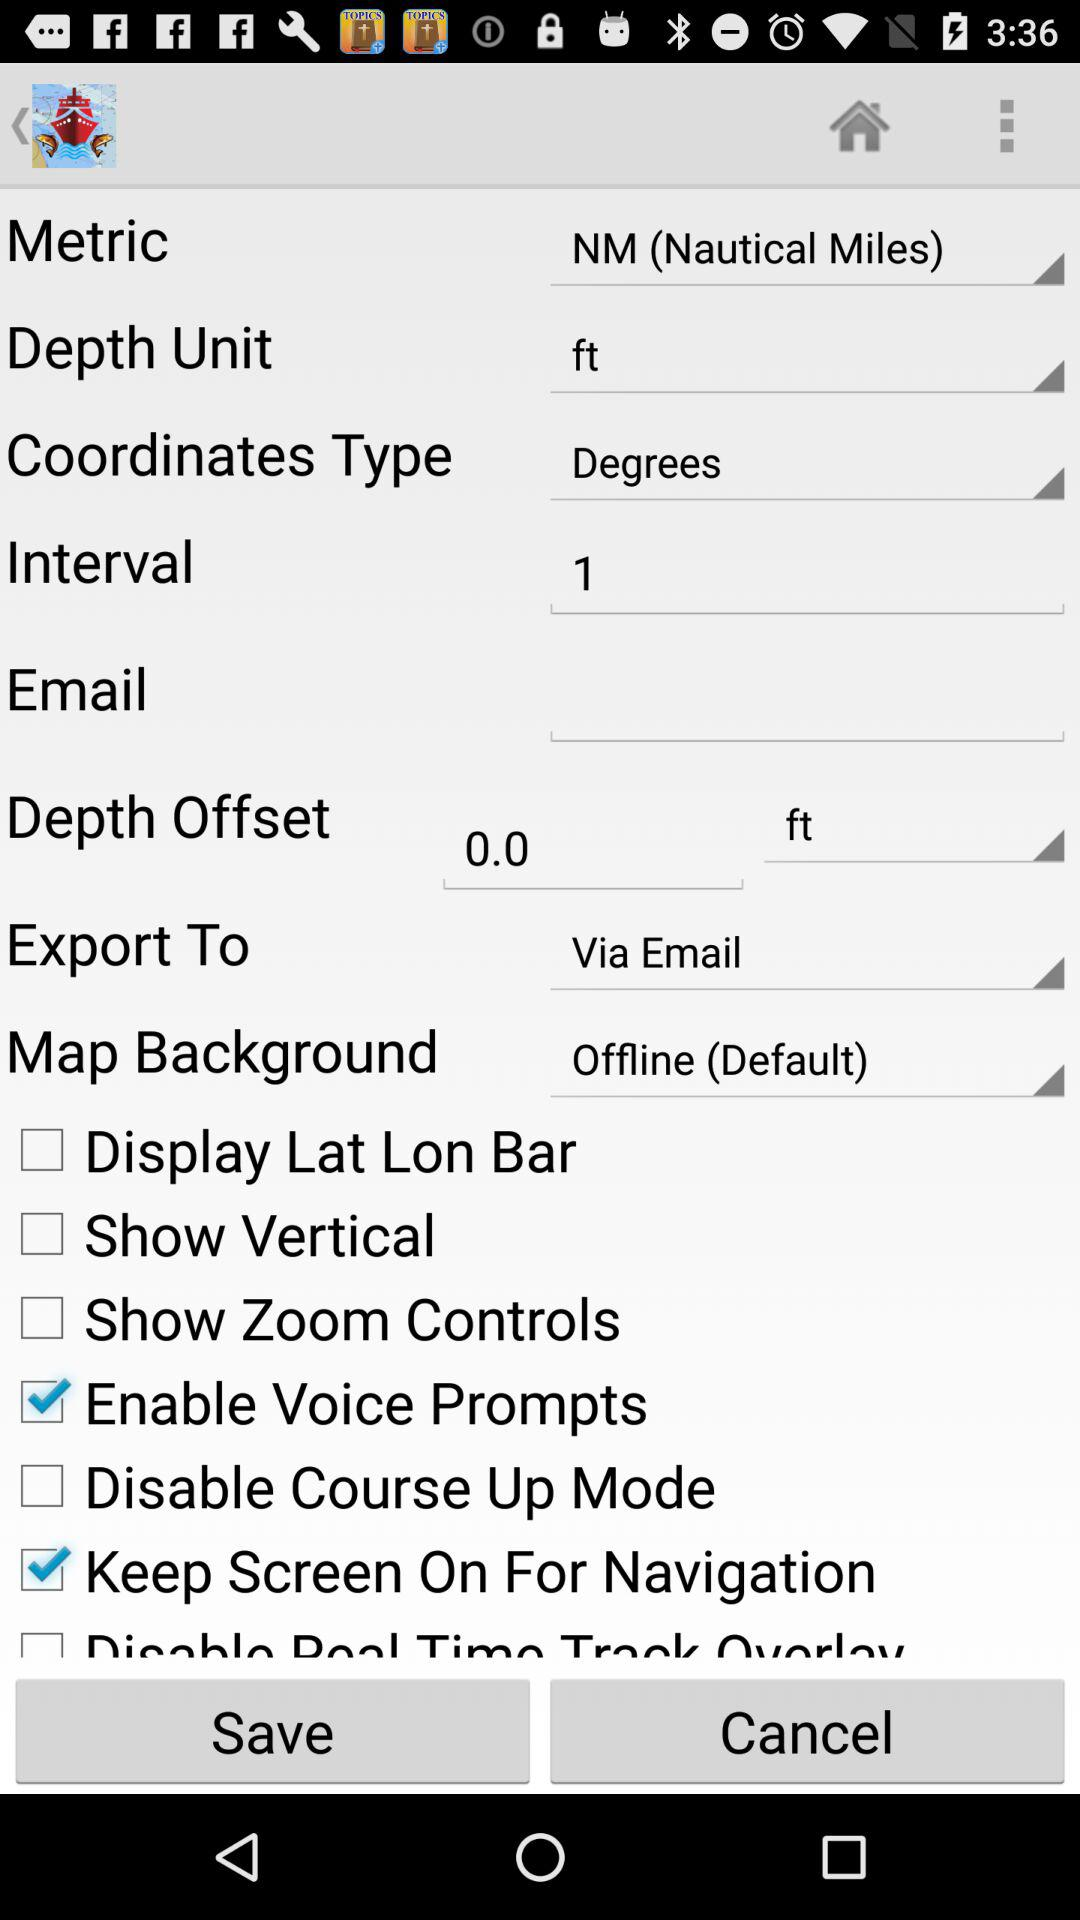Where can we export to? You can export to "Via Email". 